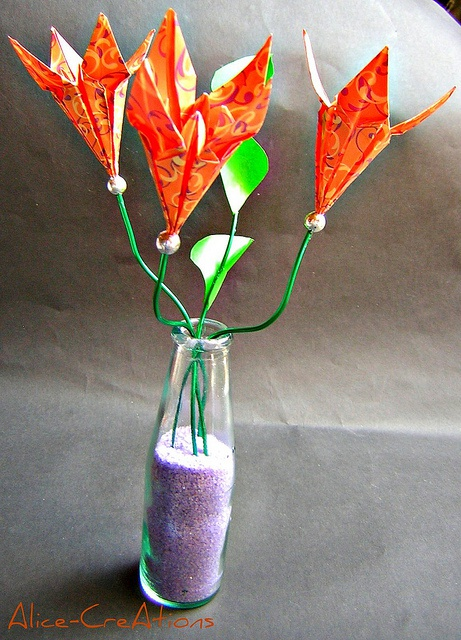Describe the objects in this image and their specific colors. I can see a vase in gray, lavender, and darkgray tones in this image. 